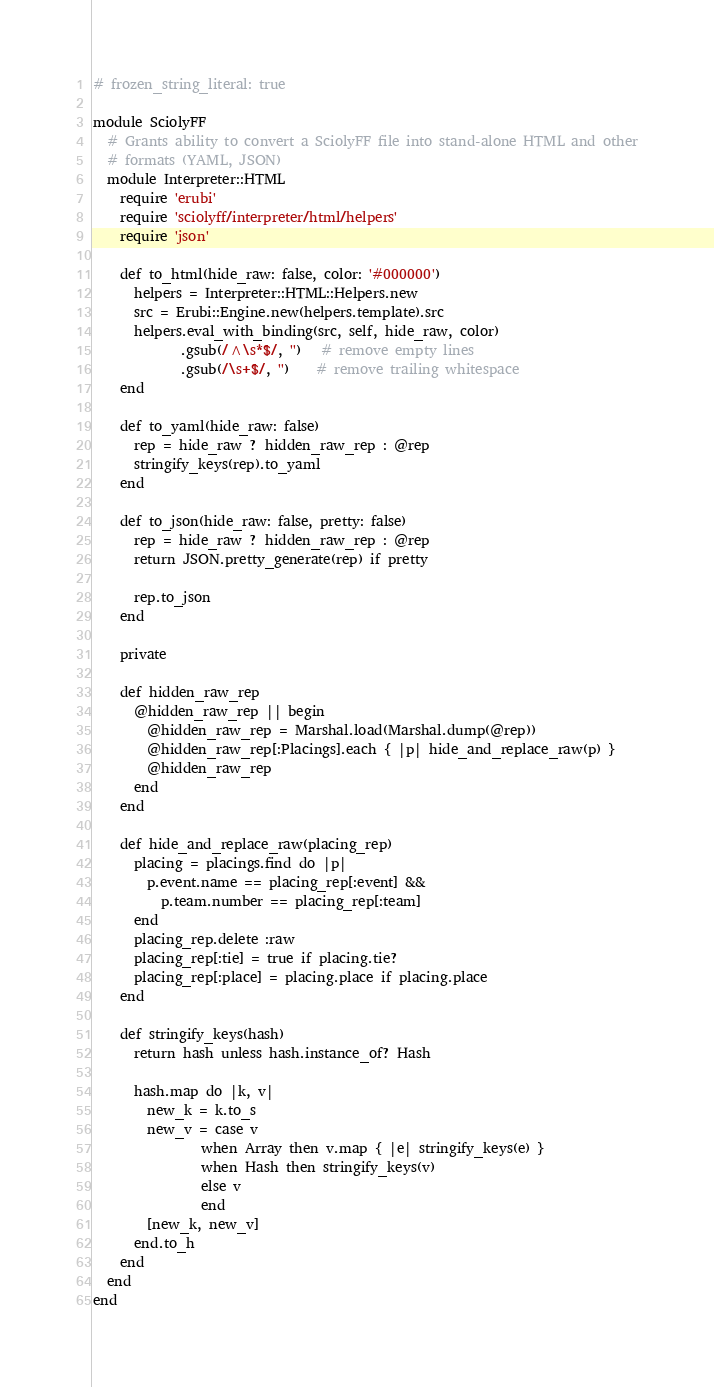<code> <loc_0><loc_0><loc_500><loc_500><_Ruby_># frozen_string_literal: true

module SciolyFF
  # Grants ability to convert a SciolyFF file into stand-alone HTML and other
  # formats (YAML, JSON)
  module Interpreter::HTML
    require 'erubi'
    require 'sciolyff/interpreter/html/helpers'
    require 'json'

    def to_html(hide_raw: false, color: '#000000')
      helpers = Interpreter::HTML::Helpers.new
      src = Erubi::Engine.new(helpers.template).src
      helpers.eval_with_binding(src, self, hide_raw, color)
             .gsub(/^\s*$/, '')   # remove empty lines
             .gsub(/\s+$/, '')    # remove trailing whitespace
    end

    def to_yaml(hide_raw: false)
      rep = hide_raw ? hidden_raw_rep : @rep
      stringify_keys(rep).to_yaml
    end

    def to_json(hide_raw: false, pretty: false)
      rep = hide_raw ? hidden_raw_rep : @rep
      return JSON.pretty_generate(rep) if pretty

      rep.to_json
    end

    private

    def hidden_raw_rep
      @hidden_raw_rep || begin
        @hidden_raw_rep = Marshal.load(Marshal.dump(@rep))
        @hidden_raw_rep[:Placings].each { |p| hide_and_replace_raw(p) }
        @hidden_raw_rep
      end
    end

    def hide_and_replace_raw(placing_rep)
      placing = placings.find do |p|
        p.event.name == placing_rep[:event] &&
          p.team.number == placing_rep[:team]
      end
      placing_rep.delete :raw
      placing_rep[:tie] = true if placing.tie?
      placing_rep[:place] = placing.place if placing.place
    end

    def stringify_keys(hash)
      return hash unless hash.instance_of? Hash

      hash.map do |k, v|
        new_k = k.to_s
        new_v = case v
                when Array then v.map { |e| stringify_keys(e) }
                when Hash then stringify_keys(v)
                else v
                end
        [new_k, new_v]
      end.to_h
    end
  end
end
</code> 